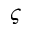<formula> <loc_0><loc_0><loc_500><loc_500>\varsigma</formula> 